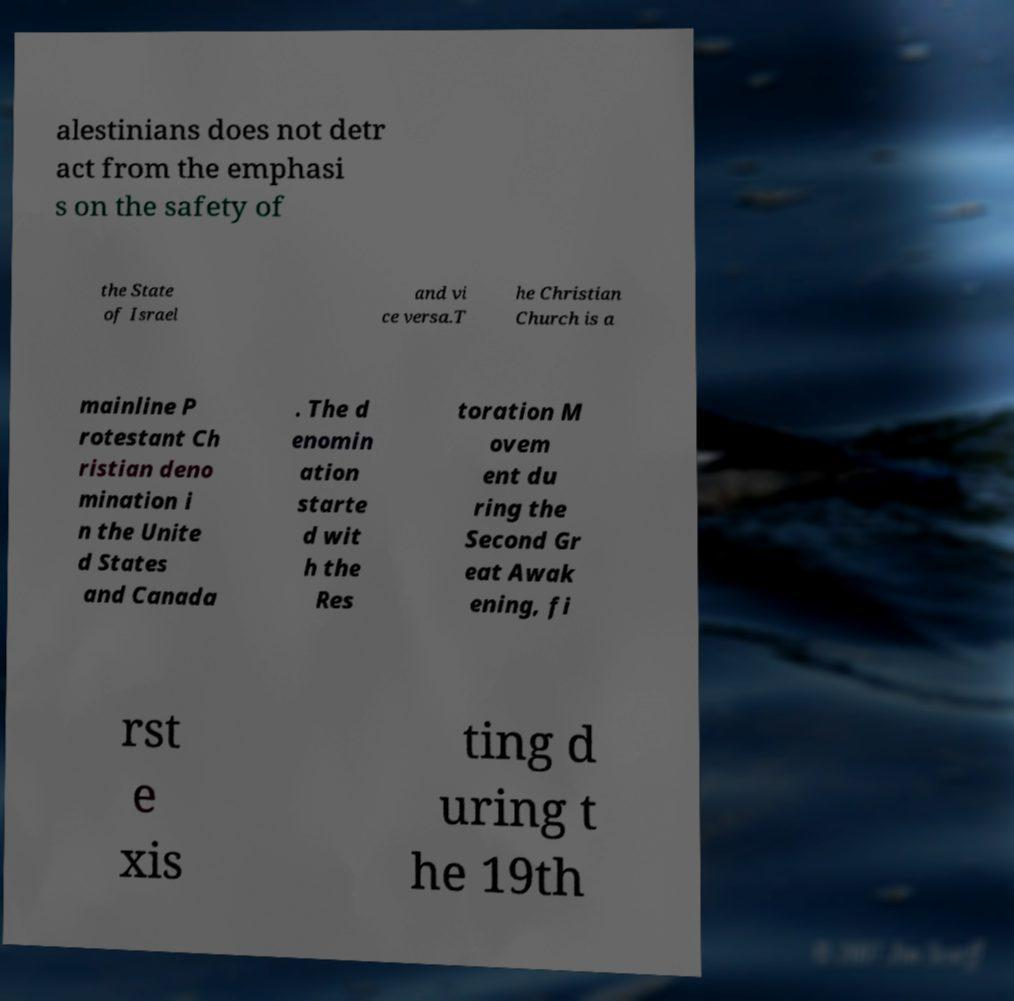Please read and relay the text visible in this image. What does it say? alestinians does not detr act from the emphasi s on the safety of the State of Israel and vi ce versa.T he Christian Church is a mainline P rotestant Ch ristian deno mination i n the Unite d States and Canada . The d enomin ation starte d wit h the Res toration M ovem ent du ring the Second Gr eat Awak ening, fi rst e xis ting d uring t he 19th 